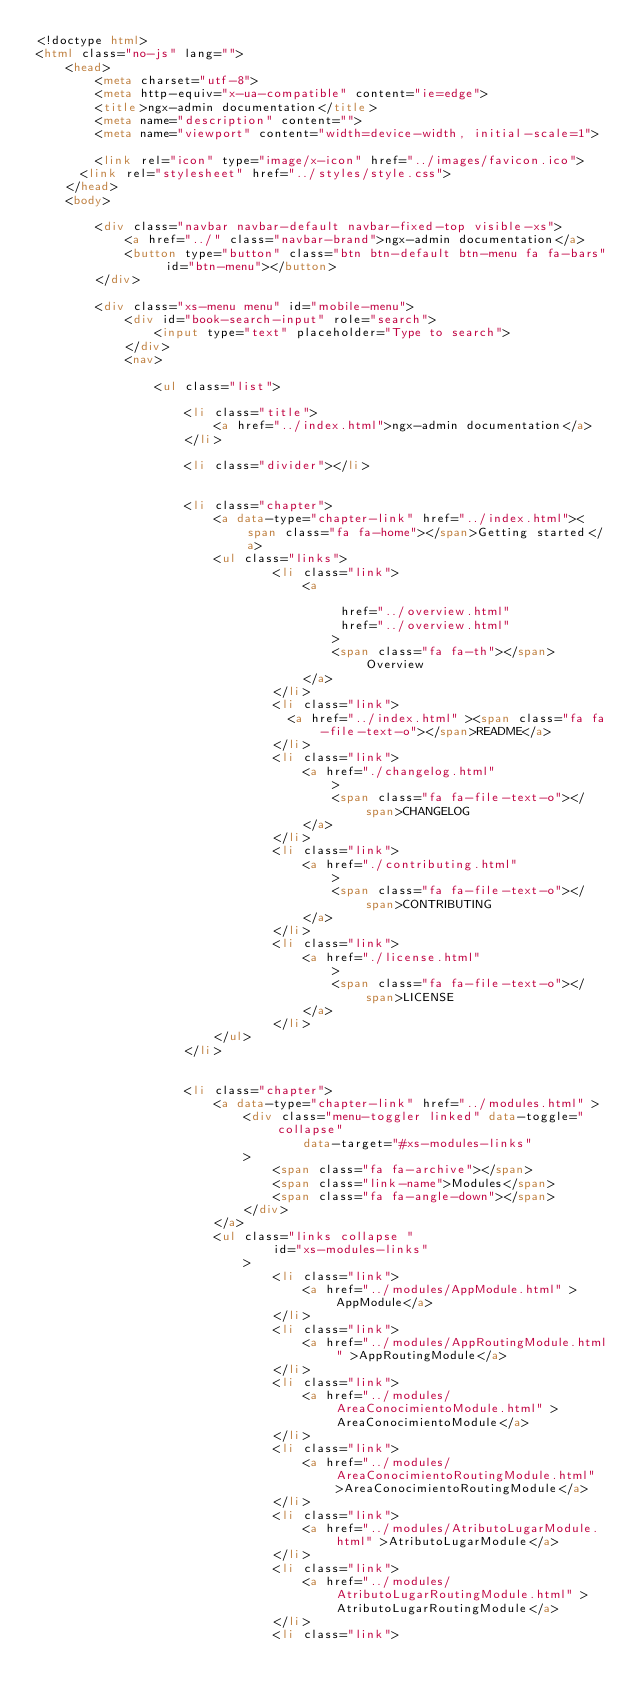Convert code to text. <code><loc_0><loc_0><loc_500><loc_500><_HTML_><!doctype html>
<html class="no-js" lang="">
    <head>
        <meta charset="utf-8">
        <meta http-equiv="x-ua-compatible" content="ie=edge">
        <title>ngx-admin documentation</title>
        <meta name="description" content="">
        <meta name="viewport" content="width=device-width, initial-scale=1">

        <link rel="icon" type="image/x-icon" href="../images/favicon.ico">
	    <link rel="stylesheet" href="../styles/style.css">
    </head>
    <body>

        <div class="navbar navbar-default navbar-fixed-top visible-xs">
            <a href="../" class="navbar-brand">ngx-admin documentation</a>
            <button type="button" class="btn btn-default btn-menu fa fa-bars" id="btn-menu"></button>
        </div>

        <div class="xs-menu menu" id="mobile-menu">
            <div id="book-search-input" role="search">
                <input type="text" placeholder="Type to search">
            </div>
            <nav>
            
                <ul class="list">
            
                    <li class="title">
                        <a href="../index.html">ngx-admin documentation</a>
                    </li>
            
                    <li class="divider"></li>
            
            
                    <li class="chapter">
                        <a data-type="chapter-link" href="../index.html"><span class="fa fa-home"></span>Getting started</a>
                        <ul class="links">
                                <li class="link">
                                    <a 
                                        
                                         href="../overview.html" 
                                         href="../overview.html" 
                                        >
                                        <span class="fa fa-th"></span>Overview
                                    </a>
                                </li>
                                <li class="link">
                                  <a href="../index.html" ><span class="fa fa-file-text-o"></span>README</a>
                                </li>
                                <li class="link">
                                    <a href="./changelog.html"
                                        >
                                        <span class="fa fa-file-text-o"></span>CHANGELOG
                                    </a>
                                </li>
                                <li class="link">
                                    <a href="./contributing.html"
                                        >
                                        <span class="fa fa-file-text-o"></span>CONTRIBUTING
                                    </a>
                                </li>
                                <li class="link">
                                    <a href="./license.html"
                                        >
                                        <span class="fa fa-file-text-o"></span>LICENSE
                                    </a>
                                </li>
                        </ul>
                    </li>
            
            
                    <li class="chapter">
                        <a data-type="chapter-link" href="../modules.html" >
                            <div class="menu-toggler linked" data-toggle="collapse"
                                    data-target="#xs-modules-links"
                            >
                                <span class="fa fa-archive"></span>
                                <span class="link-name">Modules</span>
                                <span class="fa fa-angle-down"></span>
                            </div>
                        </a>
                        <ul class="links collapse "
                                id="xs-modules-links"
                            >
                                <li class="link">
                                    <a href="../modules/AppModule.html" >AppModule</a>
                                </li>
                                <li class="link">
                                    <a href="../modules/AppRoutingModule.html" >AppRoutingModule</a>
                                </li>
                                <li class="link">
                                    <a href="../modules/AreaConocimientoModule.html" >AreaConocimientoModule</a>
                                </li>
                                <li class="link">
                                    <a href="../modules/AreaConocimientoRoutingModule.html" >AreaConocimientoRoutingModule</a>
                                </li>
                                <li class="link">
                                    <a href="../modules/AtributoLugarModule.html" >AtributoLugarModule</a>
                                </li>
                                <li class="link">
                                    <a href="../modules/AtributoLugarRoutingModule.html" >AtributoLugarRoutingModule</a>
                                </li>
                                <li class="link"></code> 